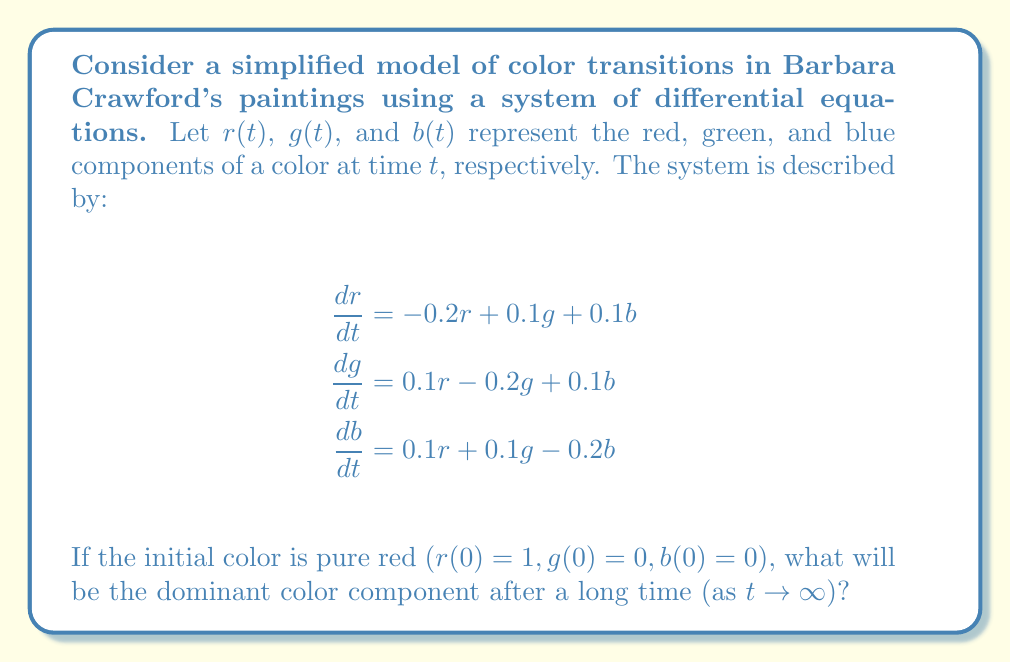Teach me how to tackle this problem. To solve this problem, we need to analyze the long-term behavior of the system:

1) First, we note that this is a linear system of differential equations. We can write it in matrix form:

   $$\frac{d}{dt}\begin{pmatrix}r \\ g \\ b\end{pmatrix} = \begin{pmatrix}-0.2 & 0.1 & 0.1 \\ 0.1 & -0.2 & 0.1 \\ 0.1 & 0.1 & -0.2\end{pmatrix}\begin{pmatrix}r \\ g \\ b\end{pmatrix}$$

2) The long-term behavior depends on the eigenvalues of this matrix. Let's call the matrix A.

3) The characteristic equation is:
   $$det(A - \lambda I) = (-0.2-\lambda)^3 + 0.1^3 + 0.1^3 - 3(0.1)^2(-0.2-\lambda) = 0$$
   
   Simplifying: $(-0.2-\lambda)^3 + 0.002 - 0.009(-0.2-\lambda) = 0$
   
   $(-0.2-\lambda)^3 + 0.002 + 0.0018 + 0.009\lambda = 0$
   
   $(-0.2-\lambda)^3 + 0.009\lambda + 0.0038 = 0$

4) This equation has three roots: $\lambda_1 = -0.3$, $\lambda_2 = \lambda_3 = -0.15$

5) Since all eigenvalues are negative, the system is stable and will converge to a steady state.

6) The eigenvector corresponding to $\lambda_1 = -0.3$ is $v_1 = (1, 1, 1)^T$

7) As $t \to \infty$, the solution will be dominated by the eigenvector corresponding to the largest eigenvalue, which is $\lambda_2 = \lambda_3 = -0.15$

8) The eigenvectors for $\lambda_2 = \lambda_3 = -0.15$ span the plane perpendicular to $v_1$

9) This means that as $t \to \infty$, the solution will approach the plane $r + g + b = c$ for some constant $c$

10) Given the symmetry of the system and the initial condition, we can conclude that $r$, $g$, and $b$ will all approach the same value as $t \to \infty$

Therefore, after a long time, all color components will be equal, resulting in a gray color with no dominant component.
Answer: No dominant color component; all components equal (gray) 